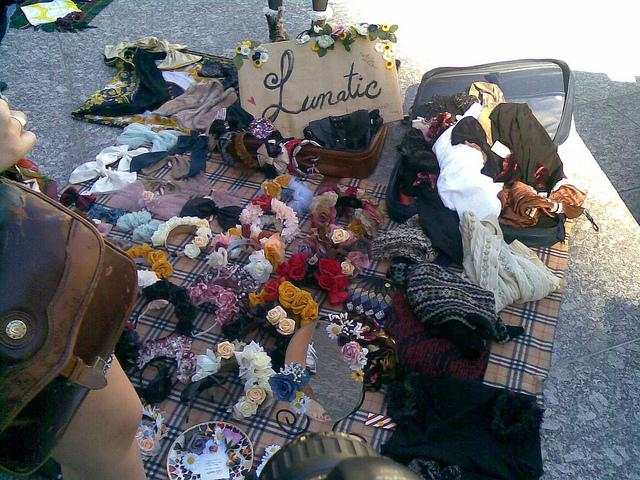Which type flower is most oft repeated here? rose 